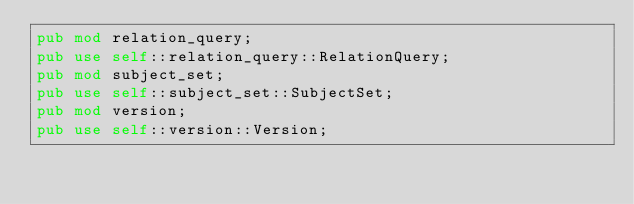Convert code to text. <code><loc_0><loc_0><loc_500><loc_500><_Rust_>pub mod relation_query;
pub use self::relation_query::RelationQuery;
pub mod subject_set;
pub use self::subject_set::SubjectSet;
pub mod version;
pub use self::version::Version;
</code> 